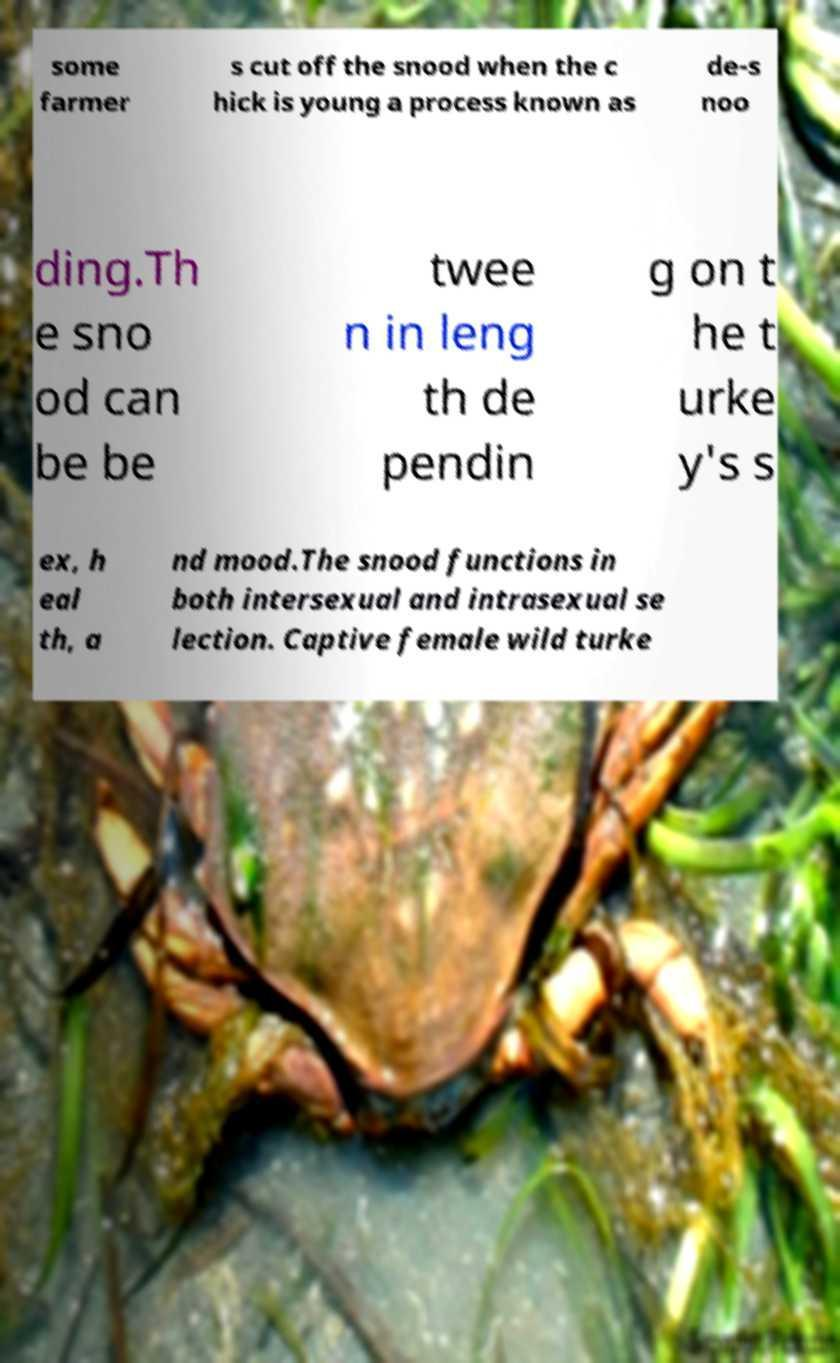Can you accurately transcribe the text from the provided image for me? some farmer s cut off the snood when the c hick is young a process known as de-s noo ding.Th e sno od can be be twee n in leng th de pendin g on t he t urke y's s ex, h eal th, a nd mood.The snood functions in both intersexual and intrasexual se lection. Captive female wild turke 